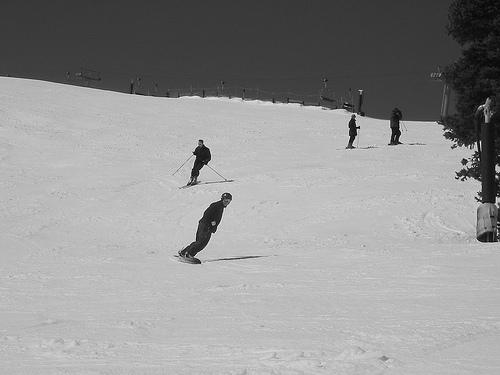Describe the environment and elements found in the background of the image. In the background, there's a ski lift with wires and seats, evergreen trees, and other people standing and skiing on the snow-covered hill. Write a short description of the image focusing on the snowboarder. A person in a winter coat and black helmet is snowboarding down a slope, leaning forward, and casting a shadow on the white snow. Mention the protective measures shown in the image. A black helmet on the snowboarder, a protective cover around a tree trunk, and ski poles in the skier's hands. Provide a brief description of the secondary character in the image. The skier, wearing a black jacket, is holding ski poles and is inclined forward as they ski down the slope behind the snowboarder. Describe the overall ambiance and setting of the image. It's a busy day on a snow-covered ski slope, with a dark sky, and people skiing and snowboarding amongst trees and ski lifts. Compose a sentence describing the weather conditions in the image. The sky appears dark and grey, suggesting cold and possibly overcast weather conditions on the ski slope. Mention the key subject and their attire in the image, along with their actions. The snowboarder, wearing a black helmet, and a winter coat is leaning forward while going down the ski slope, casting a shadow in the snow. Identify and describe the two main people in the image and their activities. A snowboarder wearing a black cap is tilting to one side, while another person in a black suit is skiing behind, holding ski poles. Write a sentence that captures the primary focus of the image. A snowboarder and skier descending a snowy hill, with the former casting a noticeable shadow on the snow. Provide a brief overview of the scene in the image. Snowboarder and skier are descending a snowy hill, with a ski lift, evergreen trees, and other people on the ski slope in the background. Notice how the ski lift is broken and not functioning in the background. No, it's not mentioned in the image. 